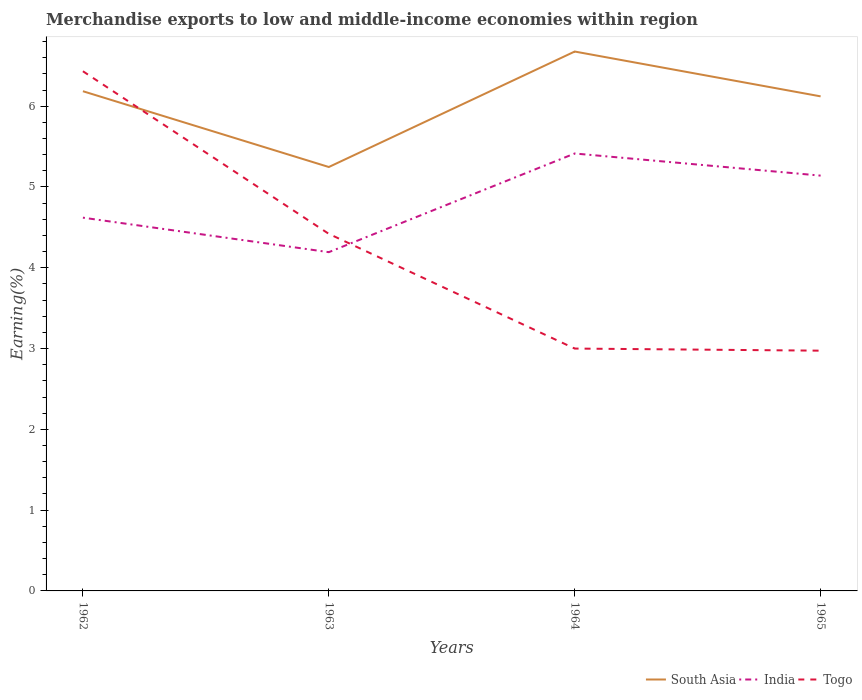How many different coloured lines are there?
Your response must be concise. 3. Is the number of lines equal to the number of legend labels?
Your response must be concise. Yes. Across all years, what is the maximum percentage of amount earned from merchandise exports in Togo?
Your answer should be compact. 2.97. In which year was the percentage of amount earned from merchandise exports in India maximum?
Ensure brevity in your answer.  1963. What is the total percentage of amount earned from merchandise exports in Togo in the graph?
Give a very brief answer. 3.43. What is the difference between the highest and the second highest percentage of amount earned from merchandise exports in India?
Your response must be concise. 1.22. What is the difference between the highest and the lowest percentage of amount earned from merchandise exports in India?
Offer a very short reply. 2. Is the percentage of amount earned from merchandise exports in Togo strictly greater than the percentage of amount earned from merchandise exports in South Asia over the years?
Your answer should be compact. No. How many lines are there?
Give a very brief answer. 3. How many years are there in the graph?
Keep it short and to the point. 4. Are the values on the major ticks of Y-axis written in scientific E-notation?
Offer a very short reply. No. Does the graph contain grids?
Make the answer very short. No. How many legend labels are there?
Keep it short and to the point. 3. How are the legend labels stacked?
Your answer should be compact. Horizontal. What is the title of the graph?
Offer a very short reply. Merchandise exports to low and middle-income economies within region. What is the label or title of the X-axis?
Ensure brevity in your answer.  Years. What is the label or title of the Y-axis?
Provide a short and direct response. Earning(%). What is the Earning(%) of South Asia in 1962?
Give a very brief answer. 6.19. What is the Earning(%) of India in 1962?
Offer a terse response. 4.62. What is the Earning(%) in Togo in 1962?
Give a very brief answer. 6.43. What is the Earning(%) in South Asia in 1963?
Your response must be concise. 5.25. What is the Earning(%) of India in 1963?
Your answer should be compact. 4.19. What is the Earning(%) in Togo in 1963?
Provide a short and direct response. 4.42. What is the Earning(%) of South Asia in 1964?
Your answer should be compact. 6.68. What is the Earning(%) of India in 1964?
Your answer should be compact. 5.41. What is the Earning(%) of Togo in 1964?
Make the answer very short. 3. What is the Earning(%) of South Asia in 1965?
Your answer should be compact. 6.12. What is the Earning(%) of India in 1965?
Keep it short and to the point. 5.14. What is the Earning(%) in Togo in 1965?
Your response must be concise. 2.97. Across all years, what is the maximum Earning(%) in South Asia?
Offer a very short reply. 6.68. Across all years, what is the maximum Earning(%) of India?
Make the answer very short. 5.41. Across all years, what is the maximum Earning(%) of Togo?
Offer a terse response. 6.43. Across all years, what is the minimum Earning(%) of South Asia?
Offer a very short reply. 5.25. Across all years, what is the minimum Earning(%) of India?
Your answer should be compact. 4.19. Across all years, what is the minimum Earning(%) of Togo?
Ensure brevity in your answer.  2.97. What is the total Earning(%) of South Asia in the graph?
Your answer should be compact. 24.23. What is the total Earning(%) in India in the graph?
Keep it short and to the point. 19.37. What is the total Earning(%) of Togo in the graph?
Give a very brief answer. 16.83. What is the difference between the Earning(%) in South Asia in 1962 and that in 1963?
Provide a short and direct response. 0.94. What is the difference between the Earning(%) in India in 1962 and that in 1963?
Offer a terse response. 0.43. What is the difference between the Earning(%) of Togo in 1962 and that in 1963?
Provide a succinct answer. 2.01. What is the difference between the Earning(%) of South Asia in 1962 and that in 1964?
Provide a short and direct response. -0.49. What is the difference between the Earning(%) in India in 1962 and that in 1964?
Provide a succinct answer. -0.79. What is the difference between the Earning(%) of Togo in 1962 and that in 1964?
Your answer should be very brief. 3.43. What is the difference between the Earning(%) of South Asia in 1962 and that in 1965?
Your answer should be compact. 0.06. What is the difference between the Earning(%) in India in 1962 and that in 1965?
Your response must be concise. -0.52. What is the difference between the Earning(%) in Togo in 1962 and that in 1965?
Offer a terse response. 3.46. What is the difference between the Earning(%) of South Asia in 1963 and that in 1964?
Make the answer very short. -1.43. What is the difference between the Earning(%) of India in 1963 and that in 1964?
Your answer should be very brief. -1.22. What is the difference between the Earning(%) in Togo in 1963 and that in 1964?
Offer a terse response. 1.42. What is the difference between the Earning(%) of South Asia in 1963 and that in 1965?
Provide a short and direct response. -0.87. What is the difference between the Earning(%) in India in 1963 and that in 1965?
Offer a terse response. -0.95. What is the difference between the Earning(%) in Togo in 1963 and that in 1965?
Your answer should be very brief. 1.45. What is the difference between the Earning(%) in South Asia in 1964 and that in 1965?
Keep it short and to the point. 0.56. What is the difference between the Earning(%) in India in 1964 and that in 1965?
Your answer should be compact. 0.27. What is the difference between the Earning(%) in Togo in 1964 and that in 1965?
Your response must be concise. 0.03. What is the difference between the Earning(%) of South Asia in 1962 and the Earning(%) of India in 1963?
Keep it short and to the point. 1.99. What is the difference between the Earning(%) of South Asia in 1962 and the Earning(%) of Togo in 1963?
Keep it short and to the point. 1.77. What is the difference between the Earning(%) of India in 1962 and the Earning(%) of Togo in 1963?
Ensure brevity in your answer.  0.2. What is the difference between the Earning(%) of South Asia in 1962 and the Earning(%) of India in 1964?
Make the answer very short. 0.77. What is the difference between the Earning(%) in South Asia in 1962 and the Earning(%) in Togo in 1964?
Ensure brevity in your answer.  3.19. What is the difference between the Earning(%) of India in 1962 and the Earning(%) of Togo in 1964?
Offer a very short reply. 1.62. What is the difference between the Earning(%) of South Asia in 1962 and the Earning(%) of India in 1965?
Your response must be concise. 1.04. What is the difference between the Earning(%) of South Asia in 1962 and the Earning(%) of Togo in 1965?
Give a very brief answer. 3.21. What is the difference between the Earning(%) in India in 1962 and the Earning(%) in Togo in 1965?
Offer a very short reply. 1.65. What is the difference between the Earning(%) in South Asia in 1963 and the Earning(%) in India in 1964?
Provide a succinct answer. -0.17. What is the difference between the Earning(%) of South Asia in 1963 and the Earning(%) of Togo in 1964?
Your answer should be compact. 2.25. What is the difference between the Earning(%) of India in 1963 and the Earning(%) of Togo in 1964?
Your answer should be compact. 1.19. What is the difference between the Earning(%) in South Asia in 1963 and the Earning(%) in India in 1965?
Provide a succinct answer. 0.11. What is the difference between the Earning(%) of South Asia in 1963 and the Earning(%) of Togo in 1965?
Your answer should be compact. 2.27. What is the difference between the Earning(%) of India in 1963 and the Earning(%) of Togo in 1965?
Offer a terse response. 1.22. What is the difference between the Earning(%) of South Asia in 1964 and the Earning(%) of India in 1965?
Provide a succinct answer. 1.54. What is the difference between the Earning(%) in South Asia in 1964 and the Earning(%) in Togo in 1965?
Provide a succinct answer. 3.7. What is the difference between the Earning(%) of India in 1964 and the Earning(%) of Togo in 1965?
Provide a succinct answer. 2.44. What is the average Earning(%) in South Asia per year?
Offer a terse response. 6.06. What is the average Earning(%) in India per year?
Ensure brevity in your answer.  4.84. What is the average Earning(%) of Togo per year?
Provide a short and direct response. 4.21. In the year 1962, what is the difference between the Earning(%) of South Asia and Earning(%) of India?
Your answer should be compact. 1.57. In the year 1962, what is the difference between the Earning(%) in South Asia and Earning(%) in Togo?
Ensure brevity in your answer.  -0.25. In the year 1962, what is the difference between the Earning(%) of India and Earning(%) of Togo?
Your answer should be compact. -1.81. In the year 1963, what is the difference between the Earning(%) of South Asia and Earning(%) of India?
Keep it short and to the point. 1.05. In the year 1963, what is the difference between the Earning(%) in South Asia and Earning(%) in Togo?
Your response must be concise. 0.83. In the year 1963, what is the difference between the Earning(%) of India and Earning(%) of Togo?
Your answer should be compact. -0.23. In the year 1964, what is the difference between the Earning(%) of South Asia and Earning(%) of India?
Give a very brief answer. 1.26. In the year 1964, what is the difference between the Earning(%) in South Asia and Earning(%) in Togo?
Your response must be concise. 3.68. In the year 1964, what is the difference between the Earning(%) of India and Earning(%) of Togo?
Keep it short and to the point. 2.41. In the year 1965, what is the difference between the Earning(%) in South Asia and Earning(%) in India?
Ensure brevity in your answer.  0.98. In the year 1965, what is the difference between the Earning(%) in South Asia and Earning(%) in Togo?
Your response must be concise. 3.15. In the year 1965, what is the difference between the Earning(%) in India and Earning(%) in Togo?
Ensure brevity in your answer.  2.17. What is the ratio of the Earning(%) of South Asia in 1962 to that in 1963?
Keep it short and to the point. 1.18. What is the ratio of the Earning(%) in India in 1962 to that in 1963?
Your answer should be very brief. 1.1. What is the ratio of the Earning(%) of Togo in 1962 to that in 1963?
Keep it short and to the point. 1.46. What is the ratio of the Earning(%) of South Asia in 1962 to that in 1964?
Ensure brevity in your answer.  0.93. What is the ratio of the Earning(%) in India in 1962 to that in 1964?
Ensure brevity in your answer.  0.85. What is the ratio of the Earning(%) of Togo in 1962 to that in 1964?
Your answer should be very brief. 2.14. What is the ratio of the Earning(%) in South Asia in 1962 to that in 1965?
Your answer should be very brief. 1.01. What is the ratio of the Earning(%) in India in 1962 to that in 1965?
Your answer should be very brief. 0.9. What is the ratio of the Earning(%) of Togo in 1962 to that in 1965?
Provide a succinct answer. 2.16. What is the ratio of the Earning(%) of South Asia in 1963 to that in 1964?
Ensure brevity in your answer.  0.79. What is the ratio of the Earning(%) of India in 1963 to that in 1964?
Provide a succinct answer. 0.77. What is the ratio of the Earning(%) of Togo in 1963 to that in 1964?
Your answer should be very brief. 1.47. What is the ratio of the Earning(%) of South Asia in 1963 to that in 1965?
Your response must be concise. 0.86. What is the ratio of the Earning(%) of India in 1963 to that in 1965?
Your answer should be compact. 0.82. What is the ratio of the Earning(%) of Togo in 1963 to that in 1965?
Ensure brevity in your answer.  1.49. What is the ratio of the Earning(%) of South Asia in 1964 to that in 1965?
Give a very brief answer. 1.09. What is the ratio of the Earning(%) of India in 1964 to that in 1965?
Make the answer very short. 1.05. What is the ratio of the Earning(%) of Togo in 1964 to that in 1965?
Provide a succinct answer. 1.01. What is the difference between the highest and the second highest Earning(%) in South Asia?
Give a very brief answer. 0.49. What is the difference between the highest and the second highest Earning(%) of India?
Your answer should be very brief. 0.27. What is the difference between the highest and the second highest Earning(%) of Togo?
Provide a succinct answer. 2.01. What is the difference between the highest and the lowest Earning(%) of South Asia?
Provide a succinct answer. 1.43. What is the difference between the highest and the lowest Earning(%) of India?
Offer a terse response. 1.22. What is the difference between the highest and the lowest Earning(%) in Togo?
Your answer should be very brief. 3.46. 